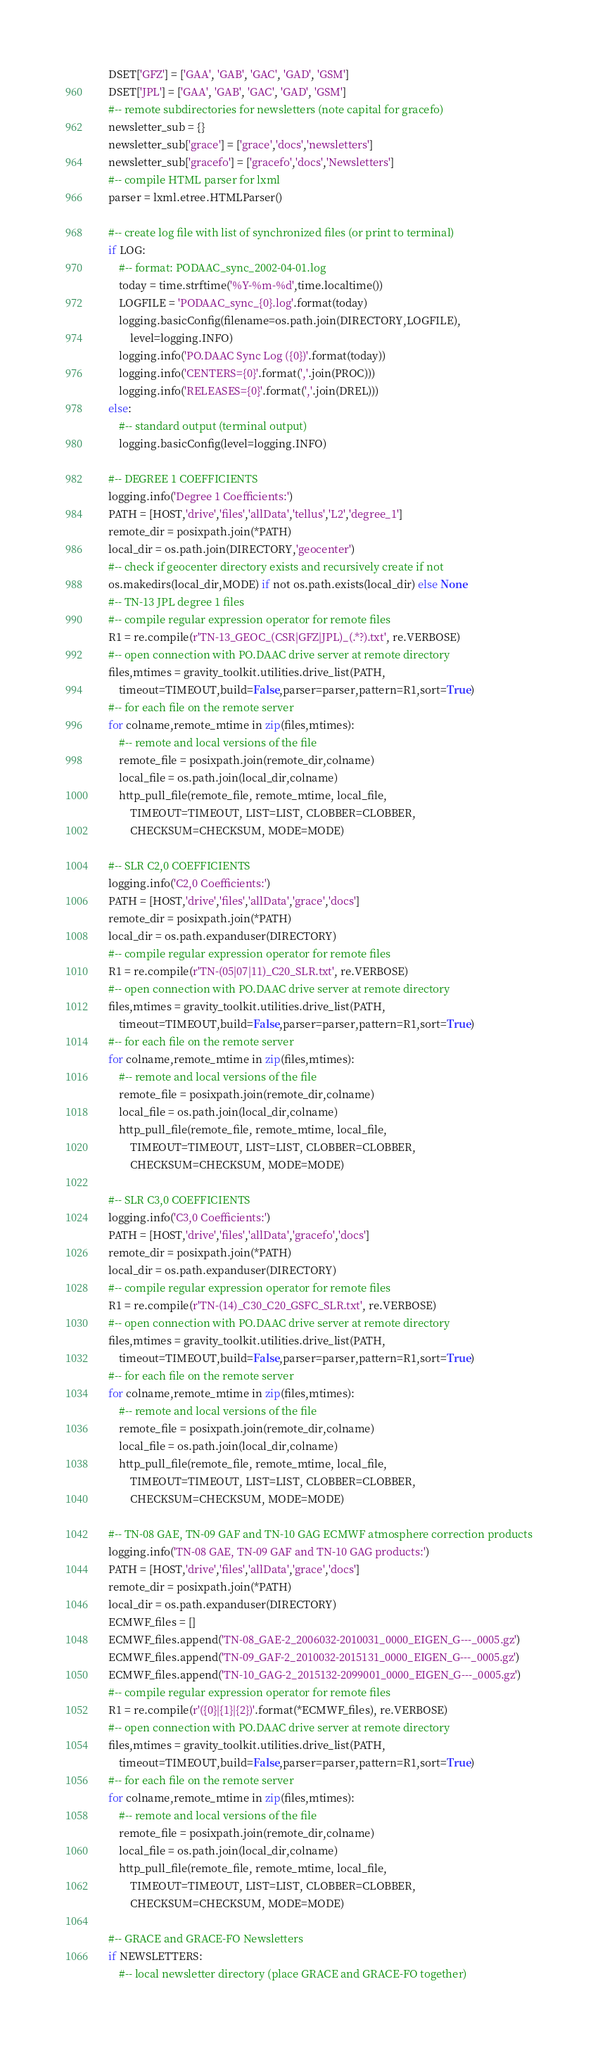<code> <loc_0><loc_0><loc_500><loc_500><_Python_>    DSET['GFZ'] = ['GAA', 'GAB', 'GAC', 'GAD', 'GSM']
    DSET['JPL'] = ['GAA', 'GAB', 'GAC', 'GAD', 'GSM']
    #-- remote subdirectories for newsletters (note capital for gracefo)
    newsletter_sub = {}
    newsletter_sub['grace'] = ['grace','docs','newsletters']
    newsletter_sub['gracefo'] = ['gracefo','docs','Newsletters']
    #-- compile HTML parser for lxml
    parser = lxml.etree.HTMLParser()

    #-- create log file with list of synchronized files (or print to terminal)
    if LOG:
        #-- format: PODAAC_sync_2002-04-01.log
        today = time.strftime('%Y-%m-%d',time.localtime())
        LOGFILE = 'PODAAC_sync_{0}.log'.format(today)
        logging.basicConfig(filename=os.path.join(DIRECTORY,LOGFILE),
            level=logging.INFO)
        logging.info('PO.DAAC Sync Log ({0})'.format(today))
        logging.info('CENTERS={0}'.format(','.join(PROC)))
        logging.info('RELEASES={0}'.format(','.join(DREL)))
    else:
        #-- standard output (terminal output)
        logging.basicConfig(level=logging.INFO)

    #-- DEGREE 1 COEFFICIENTS
    logging.info('Degree 1 Coefficients:')
    PATH = [HOST,'drive','files','allData','tellus','L2','degree_1']
    remote_dir = posixpath.join(*PATH)
    local_dir = os.path.join(DIRECTORY,'geocenter')
    #-- check if geocenter directory exists and recursively create if not
    os.makedirs(local_dir,MODE) if not os.path.exists(local_dir) else None
    #-- TN-13 JPL degree 1 files
    #-- compile regular expression operator for remote files
    R1 = re.compile(r'TN-13_GEOC_(CSR|GFZ|JPL)_(.*?).txt', re.VERBOSE)
    #-- open connection with PO.DAAC drive server at remote directory
    files,mtimes = gravity_toolkit.utilities.drive_list(PATH,
        timeout=TIMEOUT,build=False,parser=parser,pattern=R1,sort=True)
    #-- for each file on the remote server
    for colname,remote_mtime in zip(files,mtimes):
        #-- remote and local versions of the file
        remote_file = posixpath.join(remote_dir,colname)
        local_file = os.path.join(local_dir,colname)
        http_pull_file(remote_file, remote_mtime, local_file,
            TIMEOUT=TIMEOUT, LIST=LIST, CLOBBER=CLOBBER,
            CHECKSUM=CHECKSUM, MODE=MODE)

    #-- SLR C2,0 COEFFICIENTS
    logging.info('C2,0 Coefficients:')
    PATH = [HOST,'drive','files','allData','grace','docs']
    remote_dir = posixpath.join(*PATH)
    local_dir = os.path.expanduser(DIRECTORY)
    #-- compile regular expression operator for remote files
    R1 = re.compile(r'TN-(05|07|11)_C20_SLR.txt', re.VERBOSE)
    #-- open connection with PO.DAAC drive server at remote directory
    files,mtimes = gravity_toolkit.utilities.drive_list(PATH,
        timeout=TIMEOUT,build=False,parser=parser,pattern=R1,sort=True)
    #-- for each file on the remote server
    for colname,remote_mtime in zip(files,mtimes):
        #-- remote and local versions of the file
        remote_file = posixpath.join(remote_dir,colname)
        local_file = os.path.join(local_dir,colname)
        http_pull_file(remote_file, remote_mtime, local_file,
            TIMEOUT=TIMEOUT, LIST=LIST, CLOBBER=CLOBBER,
            CHECKSUM=CHECKSUM, MODE=MODE)

    #-- SLR C3,0 COEFFICIENTS
    logging.info('C3,0 Coefficients:')
    PATH = [HOST,'drive','files','allData','gracefo','docs']
    remote_dir = posixpath.join(*PATH)
    local_dir = os.path.expanduser(DIRECTORY)
    #-- compile regular expression operator for remote files
    R1 = re.compile(r'TN-(14)_C30_C20_GSFC_SLR.txt', re.VERBOSE)
    #-- open connection with PO.DAAC drive server at remote directory
    files,mtimes = gravity_toolkit.utilities.drive_list(PATH,
        timeout=TIMEOUT,build=False,parser=parser,pattern=R1,sort=True)
    #-- for each file on the remote server
    for colname,remote_mtime in zip(files,mtimes):
        #-- remote and local versions of the file
        remote_file = posixpath.join(remote_dir,colname)
        local_file = os.path.join(local_dir,colname)
        http_pull_file(remote_file, remote_mtime, local_file,
            TIMEOUT=TIMEOUT, LIST=LIST, CLOBBER=CLOBBER,
            CHECKSUM=CHECKSUM, MODE=MODE)

    #-- TN-08 GAE, TN-09 GAF and TN-10 GAG ECMWF atmosphere correction products
    logging.info('TN-08 GAE, TN-09 GAF and TN-10 GAG products:')
    PATH = [HOST,'drive','files','allData','grace','docs']
    remote_dir = posixpath.join(*PATH)
    local_dir = os.path.expanduser(DIRECTORY)
    ECMWF_files = []
    ECMWF_files.append('TN-08_GAE-2_2006032-2010031_0000_EIGEN_G---_0005.gz')
    ECMWF_files.append('TN-09_GAF-2_2010032-2015131_0000_EIGEN_G---_0005.gz')
    ECMWF_files.append('TN-10_GAG-2_2015132-2099001_0000_EIGEN_G---_0005.gz')
    #-- compile regular expression operator for remote files
    R1 = re.compile(r'({0}|{1}|{2})'.format(*ECMWF_files), re.VERBOSE)
    #-- open connection with PO.DAAC drive server at remote directory
    files,mtimes = gravity_toolkit.utilities.drive_list(PATH,
        timeout=TIMEOUT,build=False,parser=parser,pattern=R1,sort=True)
    #-- for each file on the remote server
    for colname,remote_mtime in zip(files,mtimes):
        #-- remote and local versions of the file
        remote_file = posixpath.join(remote_dir,colname)
        local_file = os.path.join(local_dir,colname)
        http_pull_file(remote_file, remote_mtime, local_file,
            TIMEOUT=TIMEOUT, LIST=LIST, CLOBBER=CLOBBER,
            CHECKSUM=CHECKSUM, MODE=MODE)

    #-- GRACE and GRACE-FO Newsletters
    if NEWSLETTERS:
        #-- local newsletter directory (place GRACE and GRACE-FO together)</code> 